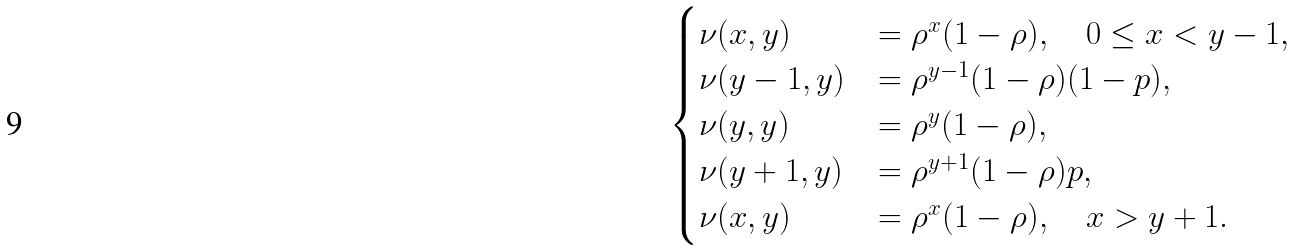Convert formula to latex. <formula><loc_0><loc_0><loc_500><loc_500>\begin{cases} \nu ( x , y ) & = \rho ^ { x } ( 1 - \rho ) , \quad 0 \leq x < y - 1 , \\ \nu ( y - 1 , y ) & = \rho ^ { y - 1 } ( 1 - \rho ) ( 1 - p ) , \\ \nu ( y , y ) & = \rho ^ { y } ( 1 - \rho ) , \\ \nu ( y + 1 , y ) & = \rho ^ { y + 1 } ( 1 - \rho ) p , \\ \nu ( x , y ) & = \rho ^ { x } ( 1 - \rho ) , \quad x > y + 1 . \end{cases}</formula> 